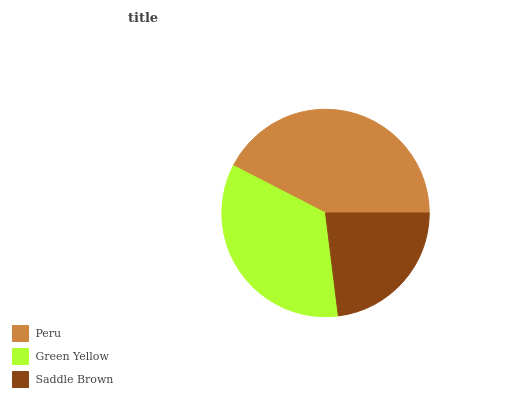Is Saddle Brown the minimum?
Answer yes or no. Yes. Is Peru the maximum?
Answer yes or no. Yes. Is Green Yellow the minimum?
Answer yes or no. No. Is Green Yellow the maximum?
Answer yes or no. No. Is Peru greater than Green Yellow?
Answer yes or no. Yes. Is Green Yellow less than Peru?
Answer yes or no. Yes. Is Green Yellow greater than Peru?
Answer yes or no. No. Is Peru less than Green Yellow?
Answer yes or no. No. Is Green Yellow the high median?
Answer yes or no. Yes. Is Green Yellow the low median?
Answer yes or no. Yes. Is Peru the high median?
Answer yes or no. No. Is Saddle Brown the low median?
Answer yes or no. No. 